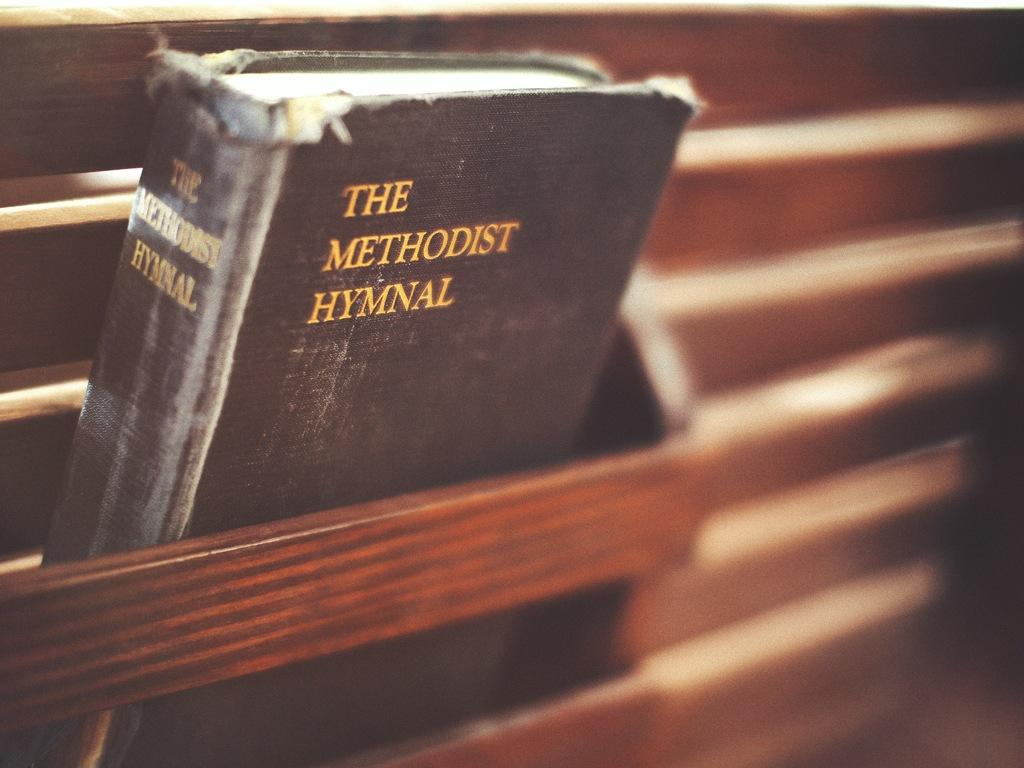<image>
Create a compact narrative representing the image presented. The back of a pew has a book called The Methodist Hymnal. 